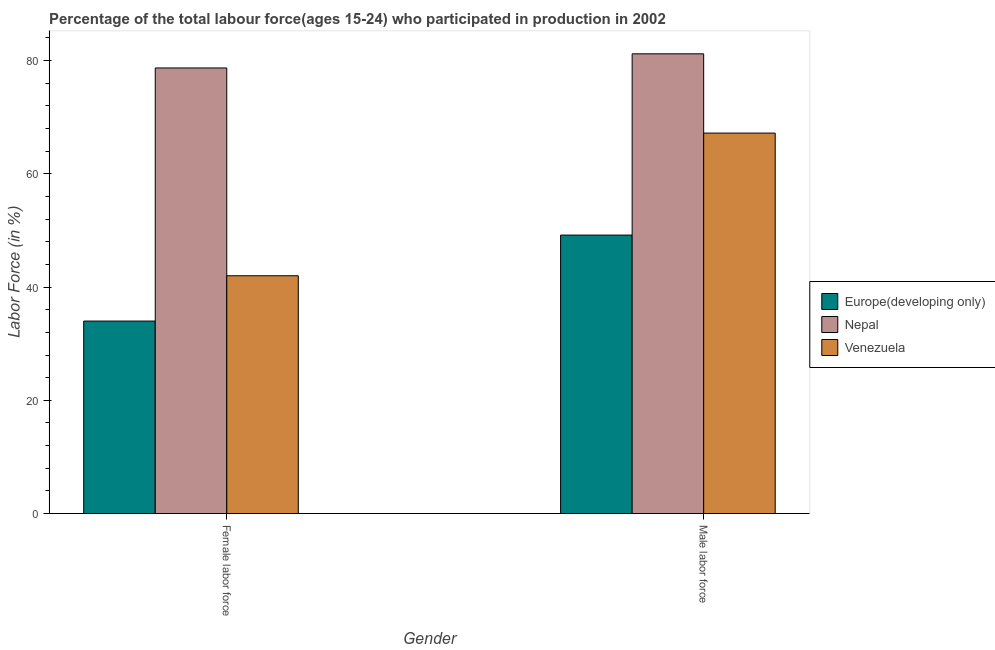How many different coloured bars are there?
Offer a very short reply. 3. Are the number of bars per tick equal to the number of legend labels?
Keep it short and to the point. Yes. How many bars are there on the 2nd tick from the left?
Give a very brief answer. 3. What is the label of the 1st group of bars from the left?
Give a very brief answer. Female labor force. What is the percentage of female labor force in Venezuela?
Provide a succinct answer. 42. Across all countries, what is the maximum percentage of female labor force?
Your answer should be very brief. 78.7. Across all countries, what is the minimum percentage of male labour force?
Your answer should be very brief. 49.18. In which country was the percentage of male labour force maximum?
Offer a very short reply. Nepal. In which country was the percentage of female labor force minimum?
Your response must be concise. Europe(developing only). What is the total percentage of male labour force in the graph?
Keep it short and to the point. 197.58. What is the difference between the percentage of male labour force in Nepal and that in Europe(developing only)?
Provide a short and direct response. 32.02. What is the difference between the percentage of female labor force in Europe(developing only) and the percentage of male labour force in Nepal?
Your response must be concise. -47.2. What is the average percentage of female labor force per country?
Your response must be concise. 51.57. What is the difference between the percentage of female labor force and percentage of male labour force in Nepal?
Offer a terse response. -2.5. What is the ratio of the percentage of male labour force in Europe(developing only) to that in Venezuela?
Keep it short and to the point. 0.73. Is the percentage of male labour force in Nepal less than that in Europe(developing only)?
Your answer should be compact. No. In how many countries, is the percentage of male labour force greater than the average percentage of male labour force taken over all countries?
Offer a terse response. 2. What does the 3rd bar from the left in Male labor force represents?
Your response must be concise. Venezuela. What does the 1st bar from the right in Female labor force represents?
Make the answer very short. Venezuela. How many bars are there?
Your response must be concise. 6. Are all the bars in the graph horizontal?
Your answer should be very brief. No. How many countries are there in the graph?
Keep it short and to the point. 3. What is the difference between two consecutive major ticks on the Y-axis?
Keep it short and to the point. 20. Are the values on the major ticks of Y-axis written in scientific E-notation?
Your response must be concise. No. Does the graph contain any zero values?
Ensure brevity in your answer.  No. Does the graph contain grids?
Make the answer very short. No. How many legend labels are there?
Your answer should be compact. 3. What is the title of the graph?
Ensure brevity in your answer.  Percentage of the total labour force(ages 15-24) who participated in production in 2002. Does "South Asia" appear as one of the legend labels in the graph?
Give a very brief answer. No. What is the label or title of the X-axis?
Give a very brief answer. Gender. What is the Labor Force (in %) of Europe(developing only) in Female labor force?
Your answer should be compact. 34. What is the Labor Force (in %) in Nepal in Female labor force?
Offer a terse response. 78.7. What is the Labor Force (in %) of Venezuela in Female labor force?
Your answer should be compact. 42. What is the Labor Force (in %) in Europe(developing only) in Male labor force?
Offer a very short reply. 49.18. What is the Labor Force (in %) of Nepal in Male labor force?
Make the answer very short. 81.2. What is the Labor Force (in %) of Venezuela in Male labor force?
Keep it short and to the point. 67.2. Across all Gender, what is the maximum Labor Force (in %) in Europe(developing only)?
Give a very brief answer. 49.18. Across all Gender, what is the maximum Labor Force (in %) of Nepal?
Keep it short and to the point. 81.2. Across all Gender, what is the maximum Labor Force (in %) of Venezuela?
Give a very brief answer. 67.2. Across all Gender, what is the minimum Labor Force (in %) of Europe(developing only)?
Give a very brief answer. 34. Across all Gender, what is the minimum Labor Force (in %) in Nepal?
Provide a succinct answer. 78.7. Across all Gender, what is the minimum Labor Force (in %) of Venezuela?
Your answer should be compact. 42. What is the total Labor Force (in %) in Europe(developing only) in the graph?
Provide a succinct answer. 83.18. What is the total Labor Force (in %) of Nepal in the graph?
Your answer should be compact. 159.9. What is the total Labor Force (in %) in Venezuela in the graph?
Keep it short and to the point. 109.2. What is the difference between the Labor Force (in %) in Europe(developing only) in Female labor force and that in Male labor force?
Ensure brevity in your answer.  -15.18. What is the difference between the Labor Force (in %) in Nepal in Female labor force and that in Male labor force?
Your answer should be compact. -2.5. What is the difference between the Labor Force (in %) of Venezuela in Female labor force and that in Male labor force?
Your response must be concise. -25.2. What is the difference between the Labor Force (in %) in Europe(developing only) in Female labor force and the Labor Force (in %) in Nepal in Male labor force?
Give a very brief answer. -47.2. What is the difference between the Labor Force (in %) in Europe(developing only) in Female labor force and the Labor Force (in %) in Venezuela in Male labor force?
Your answer should be very brief. -33.2. What is the difference between the Labor Force (in %) of Nepal in Female labor force and the Labor Force (in %) of Venezuela in Male labor force?
Ensure brevity in your answer.  11.5. What is the average Labor Force (in %) of Europe(developing only) per Gender?
Provide a succinct answer. 41.59. What is the average Labor Force (in %) in Nepal per Gender?
Your answer should be compact. 79.95. What is the average Labor Force (in %) in Venezuela per Gender?
Give a very brief answer. 54.6. What is the difference between the Labor Force (in %) in Europe(developing only) and Labor Force (in %) in Nepal in Female labor force?
Make the answer very short. -44.7. What is the difference between the Labor Force (in %) in Europe(developing only) and Labor Force (in %) in Venezuela in Female labor force?
Offer a very short reply. -8. What is the difference between the Labor Force (in %) in Nepal and Labor Force (in %) in Venezuela in Female labor force?
Provide a succinct answer. 36.7. What is the difference between the Labor Force (in %) of Europe(developing only) and Labor Force (in %) of Nepal in Male labor force?
Your response must be concise. -32.02. What is the difference between the Labor Force (in %) of Europe(developing only) and Labor Force (in %) of Venezuela in Male labor force?
Your answer should be compact. -18.02. What is the difference between the Labor Force (in %) in Nepal and Labor Force (in %) in Venezuela in Male labor force?
Provide a succinct answer. 14. What is the ratio of the Labor Force (in %) in Europe(developing only) in Female labor force to that in Male labor force?
Provide a succinct answer. 0.69. What is the ratio of the Labor Force (in %) of Nepal in Female labor force to that in Male labor force?
Give a very brief answer. 0.97. What is the difference between the highest and the second highest Labor Force (in %) of Europe(developing only)?
Your answer should be compact. 15.18. What is the difference between the highest and the second highest Labor Force (in %) in Venezuela?
Keep it short and to the point. 25.2. What is the difference between the highest and the lowest Labor Force (in %) in Europe(developing only)?
Your response must be concise. 15.18. What is the difference between the highest and the lowest Labor Force (in %) of Nepal?
Your answer should be very brief. 2.5. What is the difference between the highest and the lowest Labor Force (in %) in Venezuela?
Ensure brevity in your answer.  25.2. 